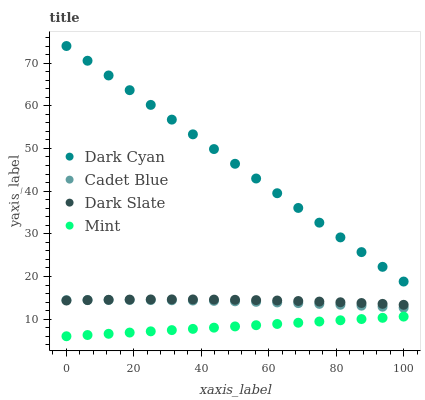Does Mint have the minimum area under the curve?
Answer yes or no. Yes. Does Dark Cyan have the maximum area under the curve?
Answer yes or no. Yes. Does Dark Slate have the minimum area under the curve?
Answer yes or no. No. Does Dark Slate have the maximum area under the curve?
Answer yes or no. No. Is Mint the smoothest?
Answer yes or no. Yes. Is Dark Slate the roughest?
Answer yes or no. Yes. Is Cadet Blue the smoothest?
Answer yes or no. No. Is Cadet Blue the roughest?
Answer yes or no. No. Does Mint have the lowest value?
Answer yes or no. Yes. Does Dark Slate have the lowest value?
Answer yes or no. No. Does Dark Cyan have the highest value?
Answer yes or no. Yes. Does Dark Slate have the highest value?
Answer yes or no. No. Is Dark Slate less than Dark Cyan?
Answer yes or no. Yes. Is Dark Slate greater than Mint?
Answer yes or no. Yes. Does Cadet Blue intersect Dark Slate?
Answer yes or no. Yes. Is Cadet Blue less than Dark Slate?
Answer yes or no. No. Is Cadet Blue greater than Dark Slate?
Answer yes or no. No. Does Dark Slate intersect Dark Cyan?
Answer yes or no. No. 